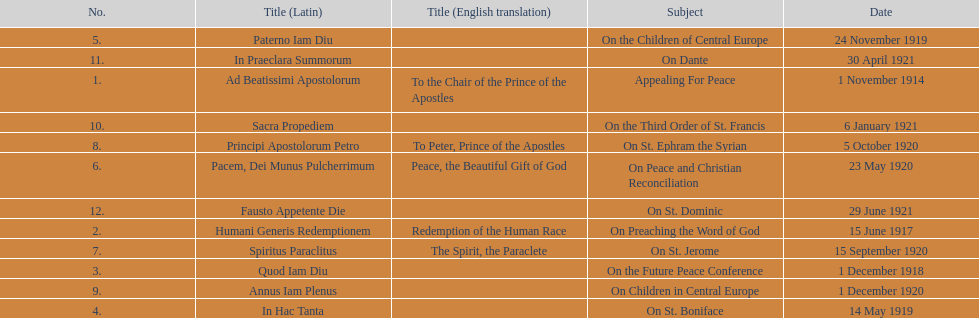What is the subject listed after appealing for peace? On Preaching the Word of God. Could you parse the entire table as a dict? {'header': ['No.', 'Title (Latin)', 'Title (English translation)', 'Subject', 'Date'], 'rows': [['5.', 'Paterno Iam Diu', '', 'On the Children of Central Europe', '24 November 1919'], ['11.', 'In Praeclara Summorum', '', 'On Dante', '30 April 1921'], ['1.', 'Ad Beatissimi Apostolorum', 'To the Chair of the Prince of the Apostles', 'Appealing For Peace', '1 November 1914'], ['10.', 'Sacra Propediem', '', 'On the Third Order of St. Francis', '6 January 1921'], ['8.', 'Principi Apostolorum Petro', 'To Peter, Prince of the Apostles', 'On St. Ephram the Syrian', '5 October 1920'], ['6.', 'Pacem, Dei Munus Pulcherrimum', 'Peace, the Beautiful Gift of God', 'On Peace and Christian Reconciliation', '23 May 1920'], ['12.', 'Fausto Appetente Die', '', 'On St. Dominic', '29 June 1921'], ['2.', 'Humani Generis Redemptionem', 'Redemption of the Human Race', 'On Preaching the Word of God', '15 June 1917'], ['7.', 'Spiritus Paraclitus', 'The Spirit, the Paraclete', 'On St. Jerome', '15 September 1920'], ['3.', 'Quod Iam Diu', '', 'On the Future Peace Conference', '1 December 1918'], ['9.', 'Annus Iam Plenus', '', 'On Children in Central Europe', '1 December 1920'], ['4.', 'In Hac Tanta', '', 'On St. Boniface', '14 May 1919']]} 